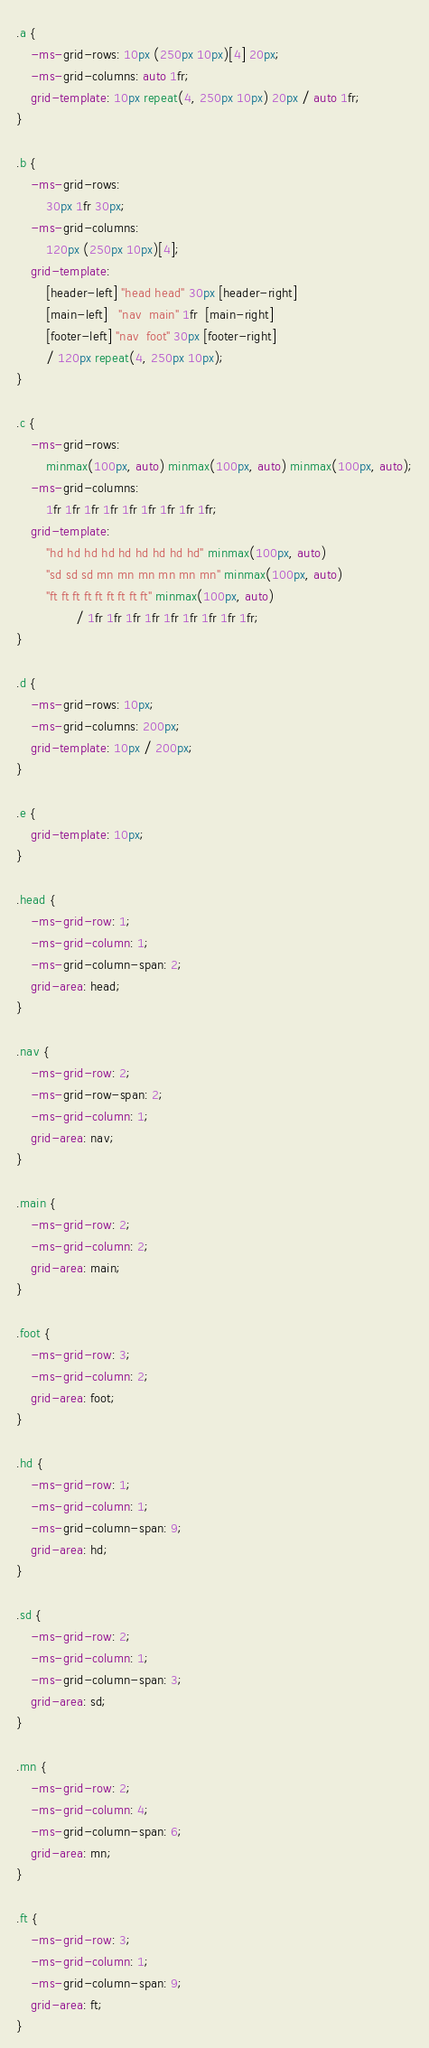<code> <loc_0><loc_0><loc_500><loc_500><_CSS_>.a {
    -ms-grid-rows: 10px (250px 10px)[4] 20px;
    -ms-grid-columns: auto 1fr;
    grid-template: 10px repeat(4, 250px 10px) 20px / auto 1fr;
}

.b {
    -ms-grid-rows:
        30px 1fr 30px;
    -ms-grid-columns:
        120px (250px 10px)[4];
    grid-template:
        [header-left] "head head" 30px [header-right]
        [main-left]   "nav  main" 1fr  [main-right]
        [footer-left] "nav  foot" 30px [footer-right]
        / 120px repeat(4, 250px 10px);
}

.c {
    -ms-grid-rows:
        minmax(100px, auto) minmax(100px, auto) minmax(100px, auto);
    -ms-grid-columns:
        1fr 1fr 1fr 1fr 1fr 1fr 1fr 1fr 1fr;
    grid-template:
        "hd hd hd hd hd hd hd hd hd" minmax(100px, auto)
        "sd sd sd mn mn mn mn mn mn" minmax(100px, auto)
        "ft ft ft ft ft ft ft ft ft" minmax(100px, auto)
                / 1fr 1fr 1fr 1fr 1fr 1fr 1fr 1fr 1fr;
}

.d {
    -ms-grid-rows: 10px;
    -ms-grid-columns: 200px;
    grid-template: 10px / 200px;
}

.e {
    grid-template: 10px;
}

.head {
    -ms-grid-row: 1;
    -ms-grid-column: 1;
    -ms-grid-column-span: 2;
    grid-area: head;
}

.nav {
    -ms-grid-row: 2;
    -ms-grid-row-span: 2;
    -ms-grid-column: 1;
    grid-area: nav;
}

.main {
    -ms-grid-row: 2;
    -ms-grid-column: 2;
    grid-area: main;
}

.foot {
    -ms-grid-row: 3;
    -ms-grid-column: 2;
    grid-area: foot;
}

.hd {
    -ms-grid-row: 1;
    -ms-grid-column: 1;
    -ms-grid-column-span: 9;
    grid-area: hd;
}

.sd {
    -ms-grid-row: 2;
    -ms-grid-column: 1;
    -ms-grid-column-span: 3;
    grid-area: sd;
}

.mn {
    -ms-grid-row: 2;
    -ms-grid-column: 4;
    -ms-grid-column-span: 6;
    grid-area: mn;
}

.ft {
    -ms-grid-row: 3;
    -ms-grid-column: 1;
    -ms-grid-column-span: 9;
    grid-area: ft;
}
</code> 